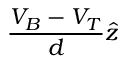Convert formula to latex. <formula><loc_0><loc_0><loc_500><loc_500>\frac { V _ { B } - V _ { T } } { d } \hat { z }</formula> 